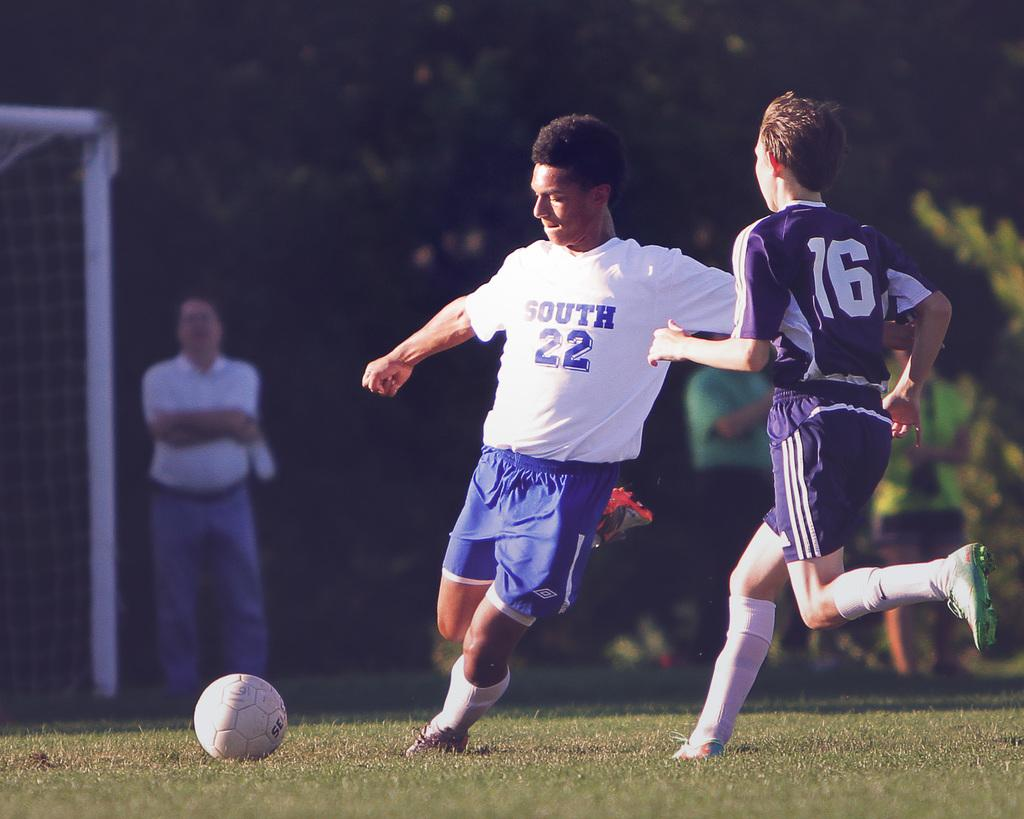<image>
Summarize the visual content of the image. the number 22 is on the shirt of a person 